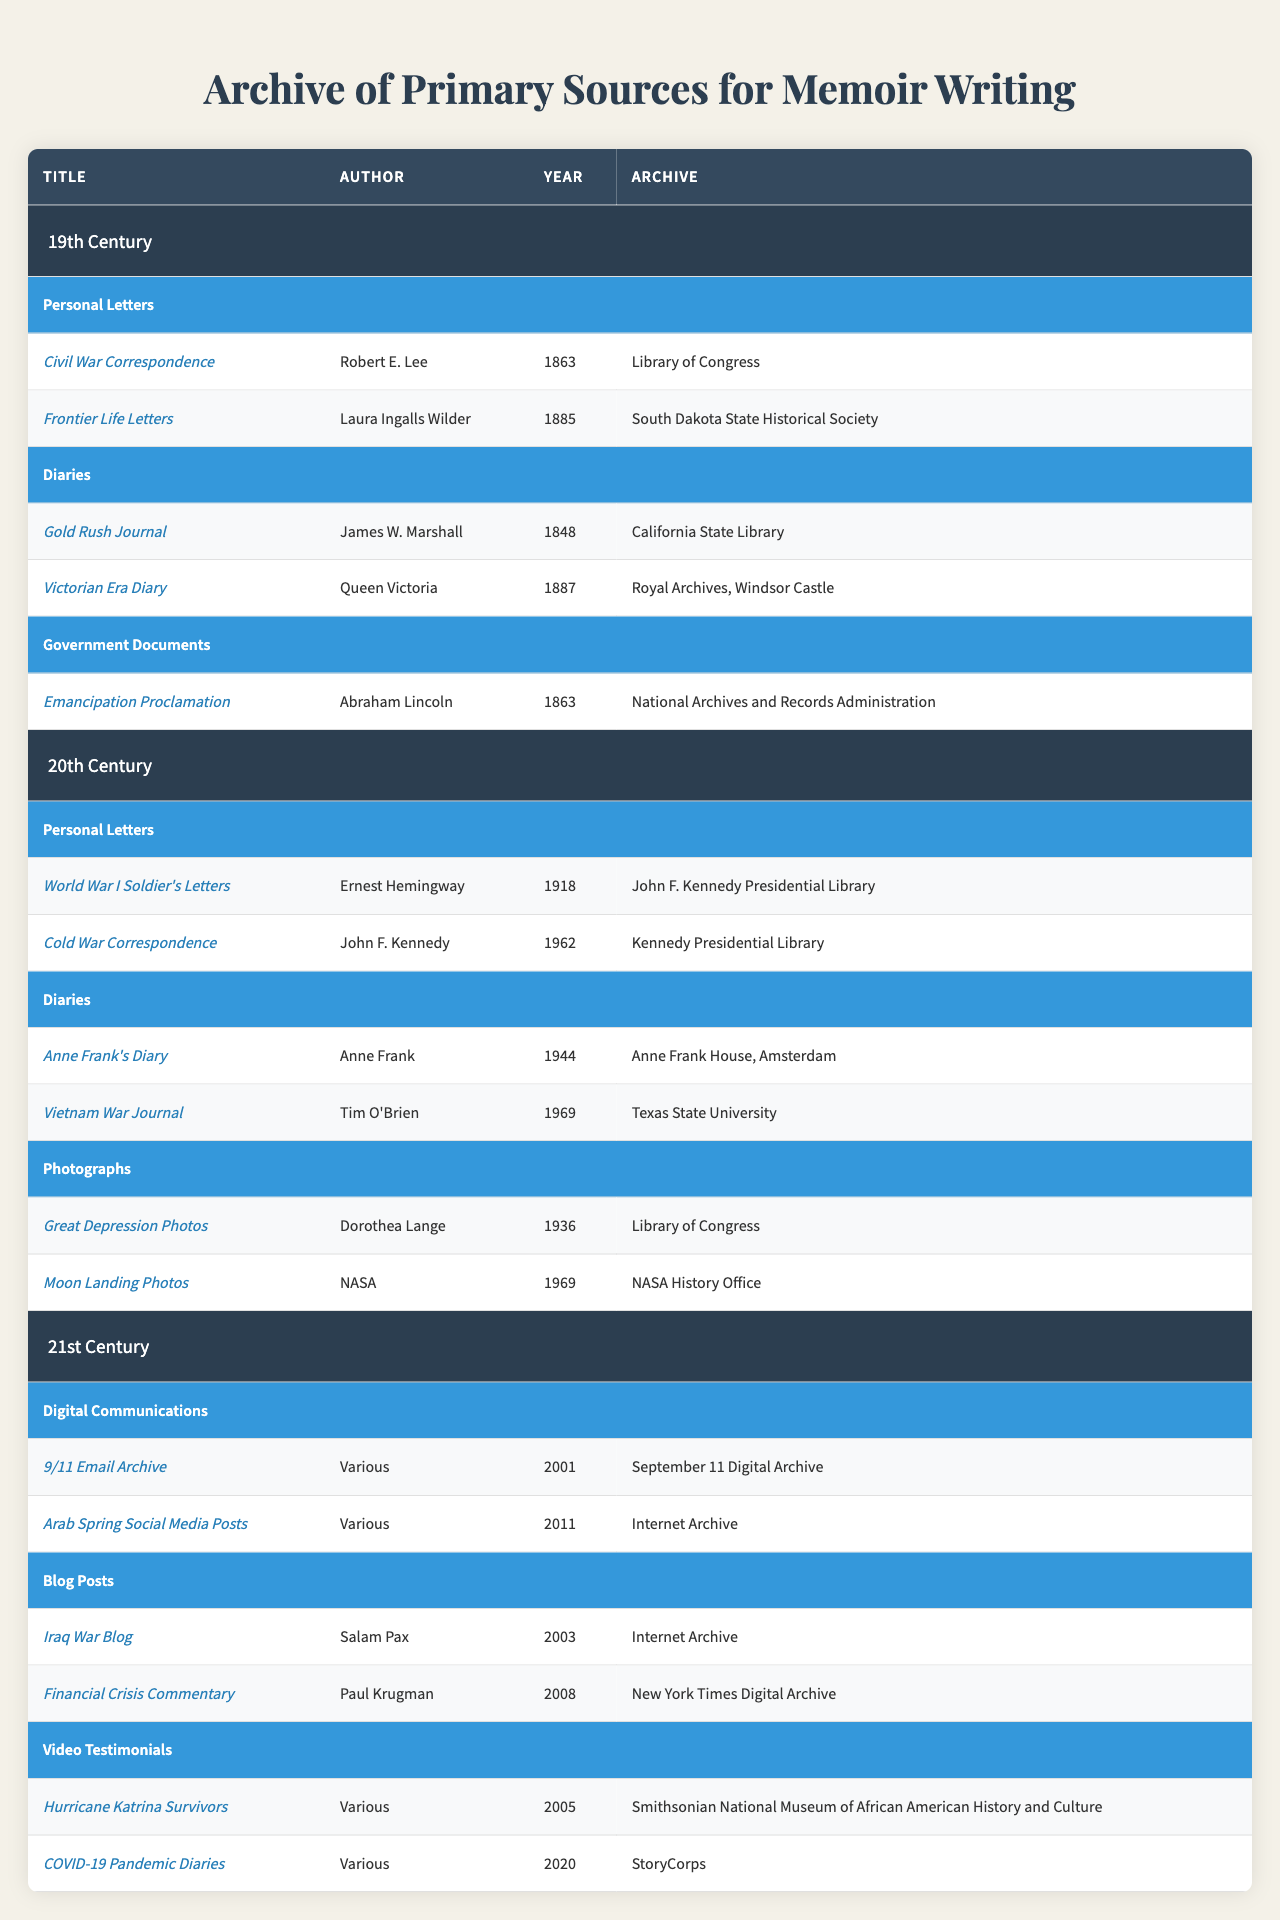What are the titles of the personal letters from the 19th Century? In the 19th Century category under Personal Letters, the table lists two titles: "Civil War Correspondence" and "Frontier Life Letters."
Answer: "Civil War Correspondence", "Frontier Life Letters" Who authored the "Great Depression Photos" and in what year was it created? The entry for "Great Depression Photos" names Dorothea Lange as the author and indicates it was created in 1936.
Answer: Dorothea Lange, 1936 Is there a diary from the 21st Century listed in the table? The table is checked under the 21st Century, and it lists Digital Communications, Blog Posts, and Video Testimonials, but there are no diaries recorded.
Answer: No How many government documents are listed from the 19th Century? The 19th Century has one entry under Government Documents, specifically the "Emancipation Proclamation" by Abraham Lincoln.
Answer: 1 Which author has two entries in the Personal Letters category? The table indicates John F. Kennedy authored two personal letters: "World War I Soldier's Letters" and "Cold War Correspondence" from the 20th Century.
Answer: John F. Kennedy What is the total number of entries in the "Diaries" section across all centuries? By counting the entries: 2 in the 19th Century (Gold Rush Journal, Victorian Era Diary), 2 in the 20th Century (Anne Frank's Diary, Vietnam War Journal), and 0 in the 21st Century, we find the total is 2 + 2 + 0 = 4.
Answer: 4 Are there any documents from the 21st Century related to a natural disaster? Yes, the "Hurricane Katrina Survivors" under Video Testimonials is related to a natural disaster, specifically Hurricane Katrina in 2005.
Answer: Yes Which document from the 20th Century corresponds to the year 1969? In the 20th Century, the "Moon Landing Photos" and "Vietnam War Journal" correspond to the year 1969.
Answer: "Moon Landing Photos", "Vietnam War Journal" What is the average year of creation for personal letters listed in the table? The letters are from 1863, 1885, 1918, and 1962. The total is 1863 + 1885 + 1918 + 1962 = 7648, divided by 4 gives an average year of 1912.
Answer: 1912 Which document about social media is found in the 21st Century? The table lists "Arab Spring Social Media Posts" under Digital Communications in the 21st Century.
Answer: "Arab Spring Social Media Posts" 